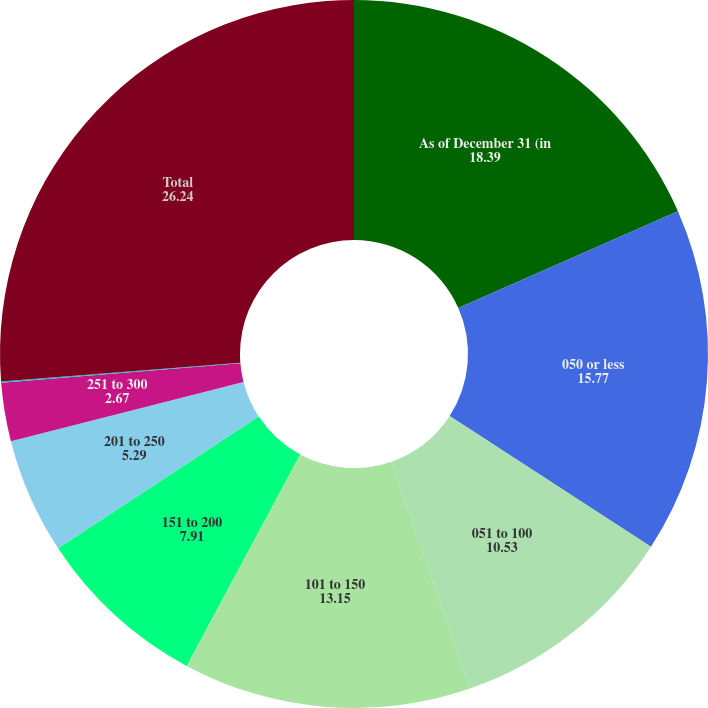<chart> <loc_0><loc_0><loc_500><loc_500><pie_chart><fcel>As of December 31 (in<fcel>050 or less<fcel>051 to 100<fcel>101 to 150<fcel>151 to 200<fcel>201 to 250<fcel>251 to 300<fcel>301 and greater<fcel>Total<nl><fcel>18.39%<fcel>15.77%<fcel>10.53%<fcel>13.15%<fcel>7.91%<fcel>5.29%<fcel>2.67%<fcel>0.05%<fcel>26.24%<nl></chart> 